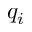Convert formula to latex. <formula><loc_0><loc_0><loc_500><loc_500>q _ { i }</formula> 